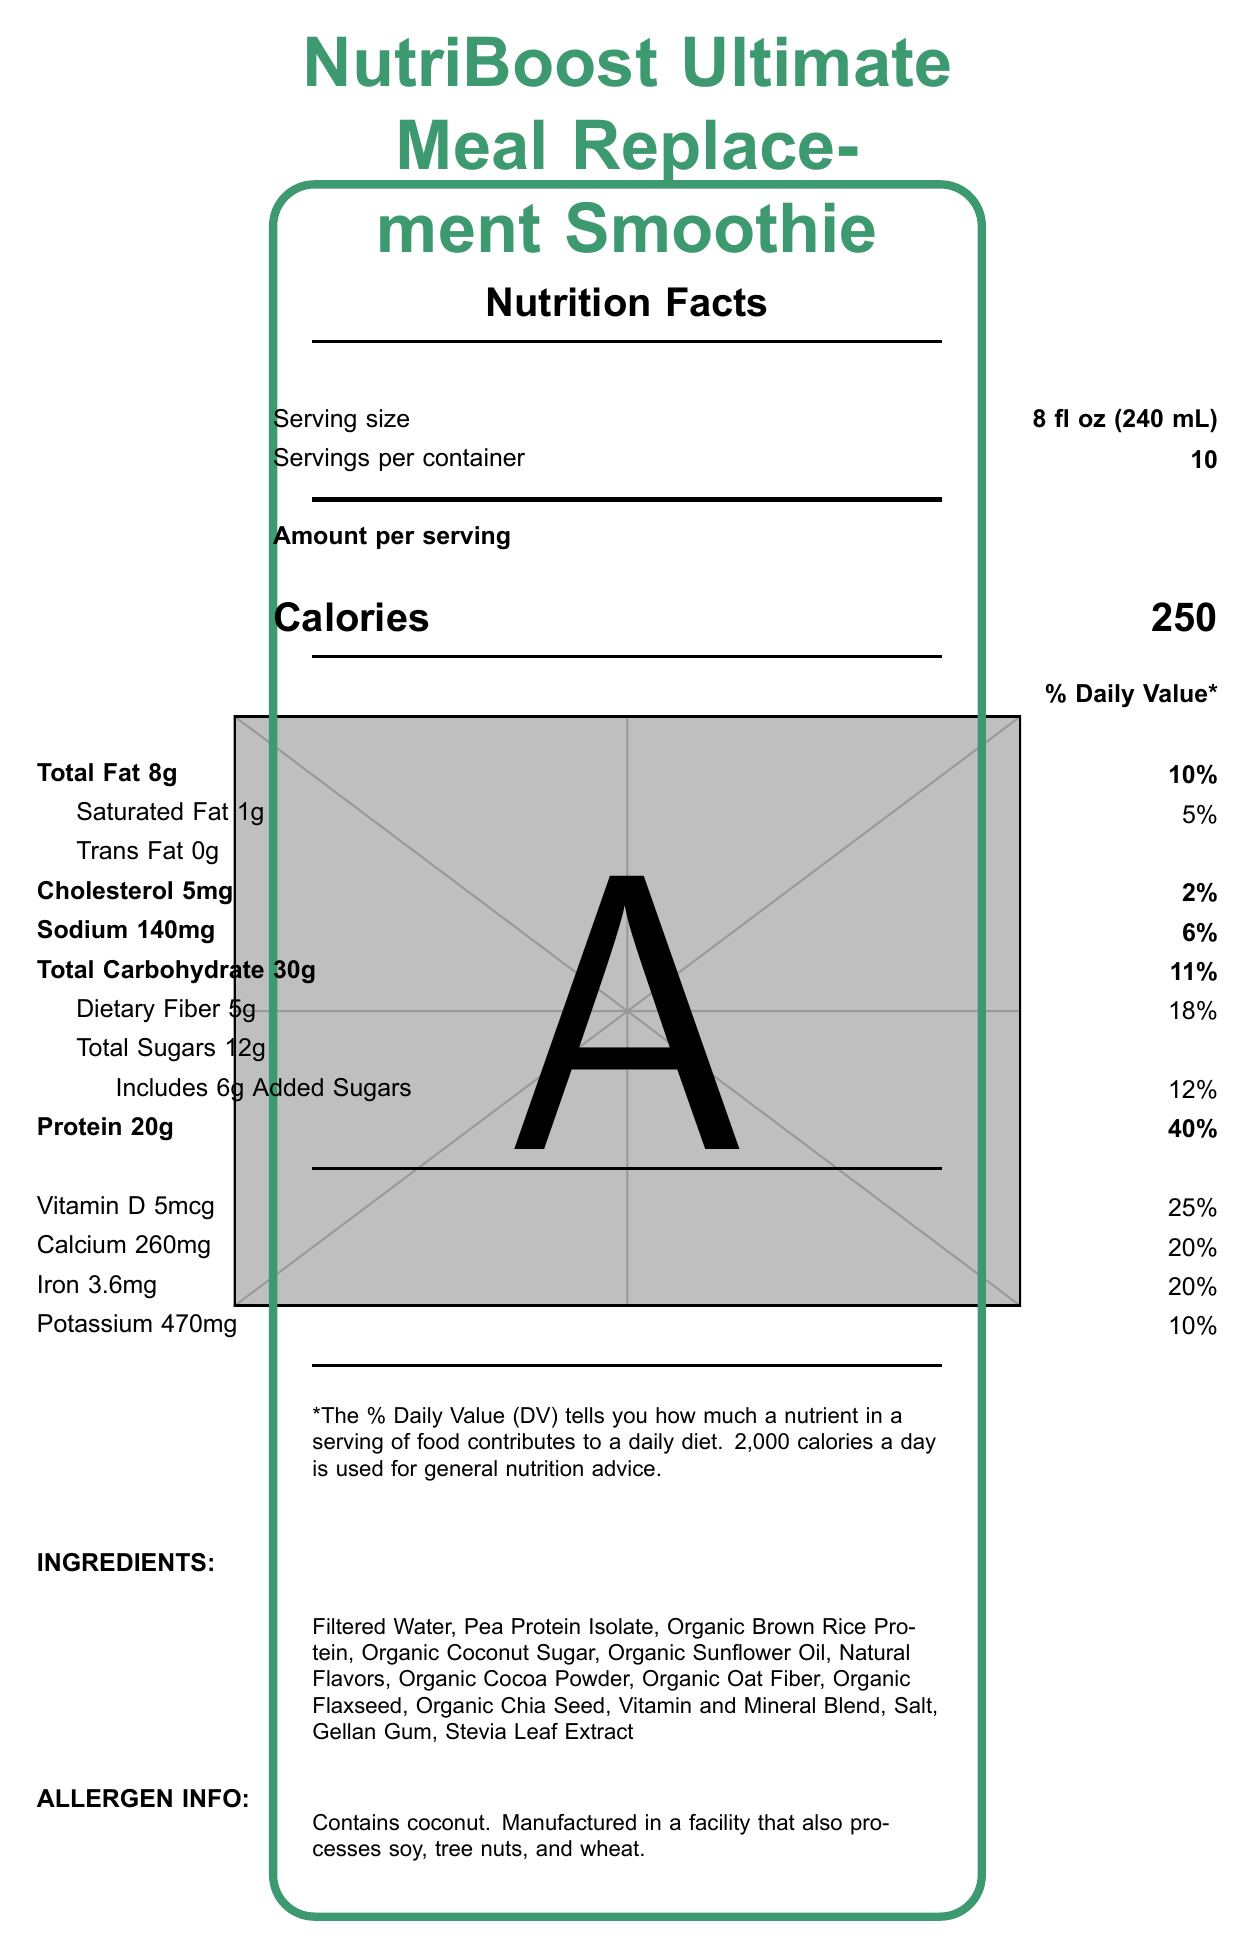what is the serving size for the smallest option? The document mentions "Serving size" for the smallest option as "8 fl oz (240 mL)".
Answer: 8 fl oz (240 mL) how many calories are in a 12 fl oz serving? The document lists "Calories" as 375 for the 12 fl oz serving size.
Answer: 375 calories how much protein is in a 16 fl oz serving? The document specifies "Protein" as 40 grams for the 16 fl oz serving.
Answer: 40 grams what is the daily value percentage of vitamin D in an 8 oz serving? The document states "Vitamin D 5mcg" and mentions "25%" in the daily value column for an 8 oz serving.
Answer: 25% are there any added sugars in the smoothie? The document indicates "Includes 6g Added Sugars" for the 8 fl oz serving, and similarly added sugars are listed for other serving sizes.
Answer: Yes how should the smoothie be stored after opening? The storage instructions in the document state "Keep refrigerated. Use within 7 days after opening."
Answer: Keep refrigerated. Use within 7 days. what type of fat has 0 grams in the smoothie? A. Saturated Fat B. Trans Fat C. Total Fat D. Dietary Fiber The document shows "Trans Fat 0g" for all serving sizes.
Answer: B how much cholesterol is in a 12 fl oz serving? A. 3mg B. 5mg C. 8mg D. 10mg The document lists "Cholesterol 8mg" for the 12 fl oz serving size.
Answer: C does the smoothie contain any allergens? The document mentions "Contains coconut" and "Manufactured in a facility that also processes soy, tree nuts, and wheat."
Answer: Yes summarize the main idea of the document. The document includes detailed nutritional information per serving size, ingredients, allergy information, storage instructions, and brand statement aimed at providing busy professionals with a nutritious meal replacement option.
Answer: The document provides the Nutrition Facts Label for "NutriBoost Ultimate Meal Replacement Smoothie," including serving size options, nutrition information (calories, fats, cholesterol, sodium, carbohydrates, fiber, sugars, protein, vitamins, and minerals). It also lists ingredients, allergens, storage instructions, and some customization tips. who is the manufacturer of the smoothie? The document does not provide any information about the manufacturer of the smoothie.
Answer: Cannot be determined 